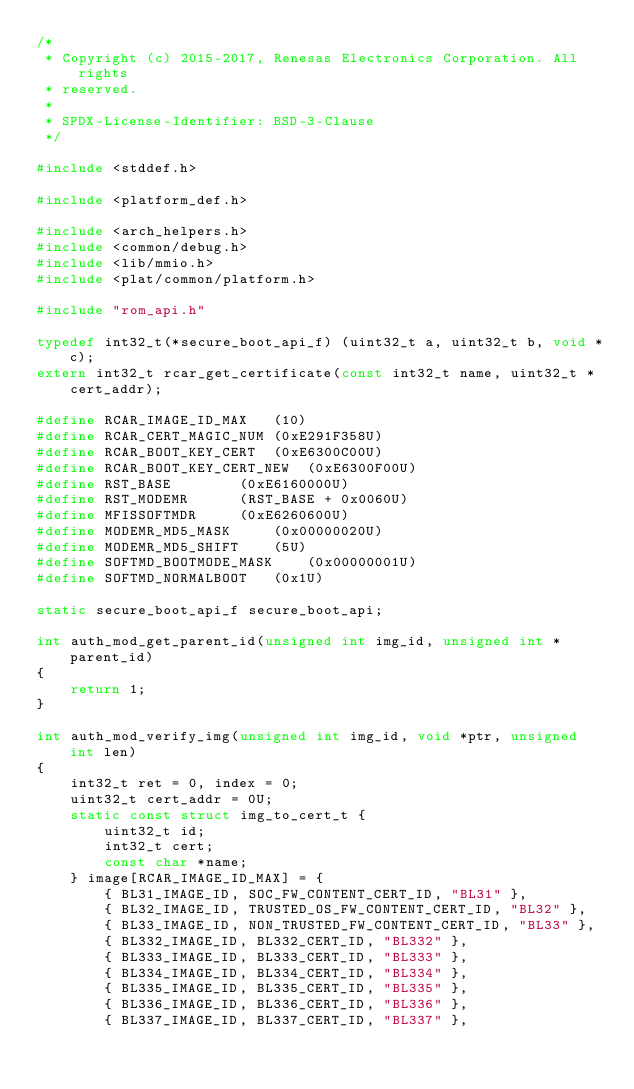<code> <loc_0><loc_0><loc_500><loc_500><_C_>/*
 * Copyright (c) 2015-2017, Renesas Electronics Corporation. All rights
 * reserved.
 *
 * SPDX-License-Identifier: BSD-3-Clause
 */

#include <stddef.h>

#include <platform_def.h>

#include <arch_helpers.h>
#include <common/debug.h>
#include <lib/mmio.h>
#include <plat/common/platform.h>

#include "rom_api.h"

typedef int32_t(*secure_boot_api_f) (uint32_t a, uint32_t b, void *c);
extern int32_t rcar_get_certificate(const int32_t name, uint32_t *cert_addr);

#define	RCAR_IMAGE_ID_MAX	(10)
#define	RCAR_CERT_MAGIC_NUM	(0xE291F358U)
#define RCAR_BOOT_KEY_CERT	(0xE6300C00U)
#define RCAR_BOOT_KEY_CERT_NEW	(0xE6300F00U)
#define	RST_BASE		(0xE6160000U)
#define	RST_MODEMR		(RST_BASE + 0x0060U)
#define	MFISSOFTMDR		(0xE6260600U)
#define	MODEMR_MD5_MASK		(0x00000020U)
#define	MODEMR_MD5_SHIFT	(5U)
#define	SOFTMD_BOOTMODE_MASK	(0x00000001U)
#define	SOFTMD_NORMALBOOT	(0x1U)

static secure_boot_api_f secure_boot_api;

int auth_mod_get_parent_id(unsigned int img_id, unsigned int *parent_id)
{
	return 1;
}

int auth_mod_verify_img(unsigned int img_id, void *ptr, unsigned int len)
{
	int32_t ret = 0, index = 0;
	uint32_t cert_addr = 0U;
	static const struct img_to_cert_t {
		uint32_t id;
		int32_t cert;
		const char *name;
	} image[RCAR_IMAGE_ID_MAX] = {
		{ BL31_IMAGE_ID, SOC_FW_CONTENT_CERT_ID, "BL31" },
		{ BL32_IMAGE_ID, TRUSTED_OS_FW_CONTENT_CERT_ID, "BL32" },
		{ BL33_IMAGE_ID, NON_TRUSTED_FW_CONTENT_CERT_ID, "BL33" },
		{ BL332_IMAGE_ID, BL332_CERT_ID, "BL332" },
		{ BL333_IMAGE_ID, BL333_CERT_ID, "BL333" },
		{ BL334_IMAGE_ID, BL334_CERT_ID, "BL334" },
		{ BL335_IMAGE_ID, BL335_CERT_ID, "BL335" },
		{ BL336_IMAGE_ID, BL336_CERT_ID, "BL336" },
		{ BL337_IMAGE_ID, BL337_CERT_ID, "BL337" },</code> 